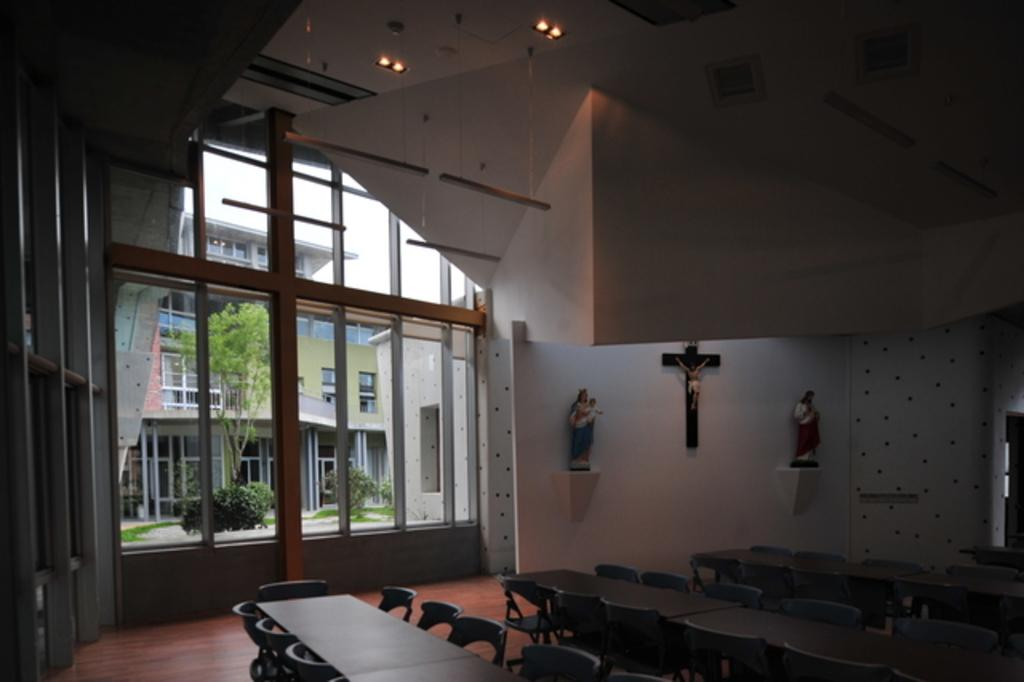What type of furniture is on the floor in the image? There are tables and chairs on the floor in the image. What can be seen on the wall in the image? There are statues on the wall in the image. What architectural feature is present in the image? There are windows in the image. What structures are visible in the image? There are buildings visible in the image. What type of vegetation is present in the image? There are trees in the image. What type of lighting is present in the image? There are lights in the image. What is visible in the background of the image? The sky is visible in the background of the image. Can you tell me how many nuts are hanging from the trees in the image? There are no nuts hanging from the trees in the image; only trees are present. What type of collar is visible on the statues in the image? There are no collars present on the statues in the image; only statues are visible on the wall. 